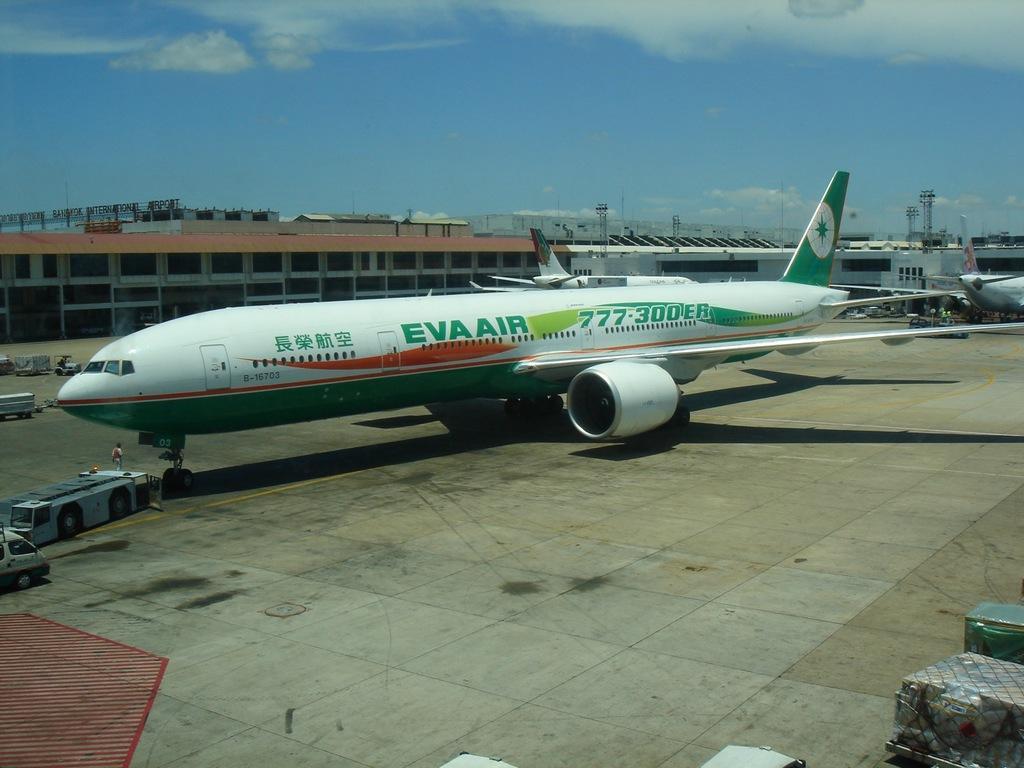In one or two sentences, can you explain what this image depicts? In this image we can see the airplanes and some vehicles on the runway. We can also see some people. On the bottom of the image we can see some containers placed on the ground. On the backside we can see some buildings, the metal frames, poles and the sky which looks cloudy. 